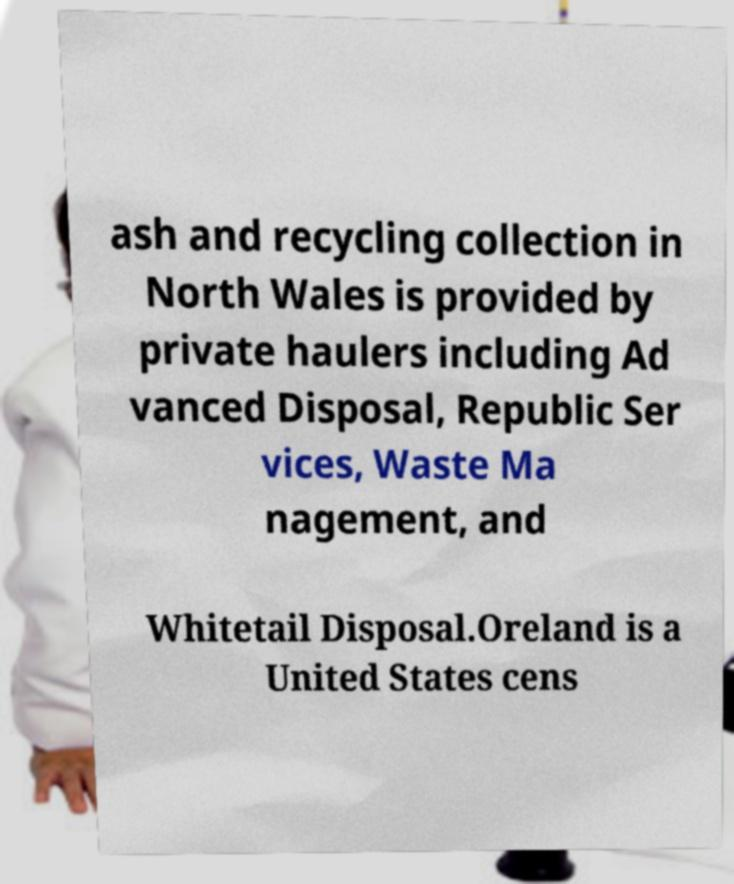I need the written content from this picture converted into text. Can you do that? ash and recycling collection in North Wales is provided by private haulers including Ad vanced Disposal, Republic Ser vices, Waste Ma nagement, and Whitetail Disposal.Oreland is a United States cens 